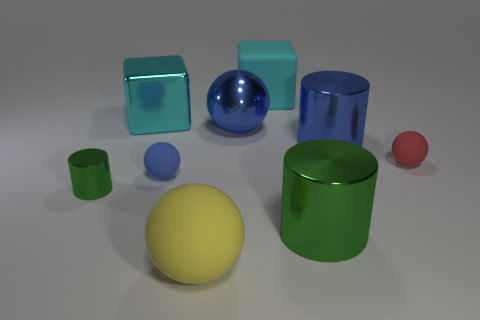Subtract all large cylinders. How many cylinders are left? 1 Subtract all blue cylinders. How many cylinders are left? 2 Add 1 big matte objects. How many objects exist? 10 Subtract all blocks. How many objects are left? 7 Subtract 1 cubes. How many cubes are left? 1 Subtract all cyan shiny blocks. Subtract all big cyan metal blocks. How many objects are left? 7 Add 8 big cyan matte things. How many big cyan matte things are left? 9 Add 6 shiny cylinders. How many shiny cylinders exist? 9 Subtract 0 yellow blocks. How many objects are left? 9 Subtract all blue cubes. Subtract all red cylinders. How many cubes are left? 2 